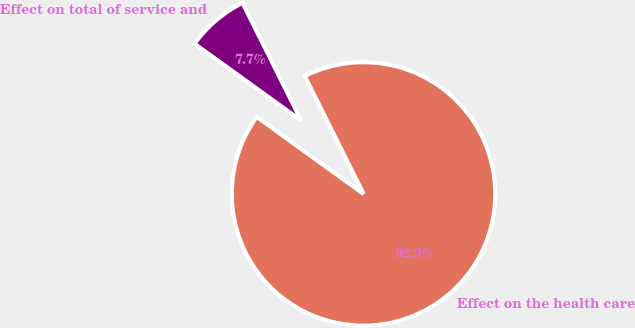<chart> <loc_0><loc_0><loc_500><loc_500><pie_chart><fcel>Effect on total of service and<fcel>Effect on the health care<nl><fcel>7.69%<fcel>92.31%<nl></chart> 